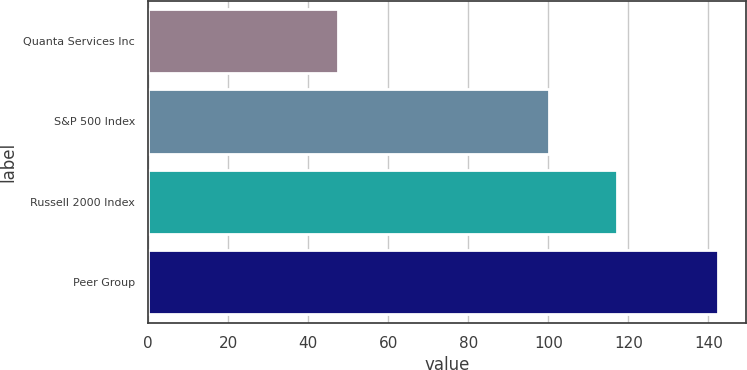Convert chart. <chart><loc_0><loc_0><loc_500><loc_500><bar_chart><fcel>Quanta Services Inc<fcel>S&P 500 Index<fcel>Russell 2000 Index<fcel>Peer Group<nl><fcel>47.31<fcel>100.24<fcel>117.09<fcel>142.28<nl></chart> 